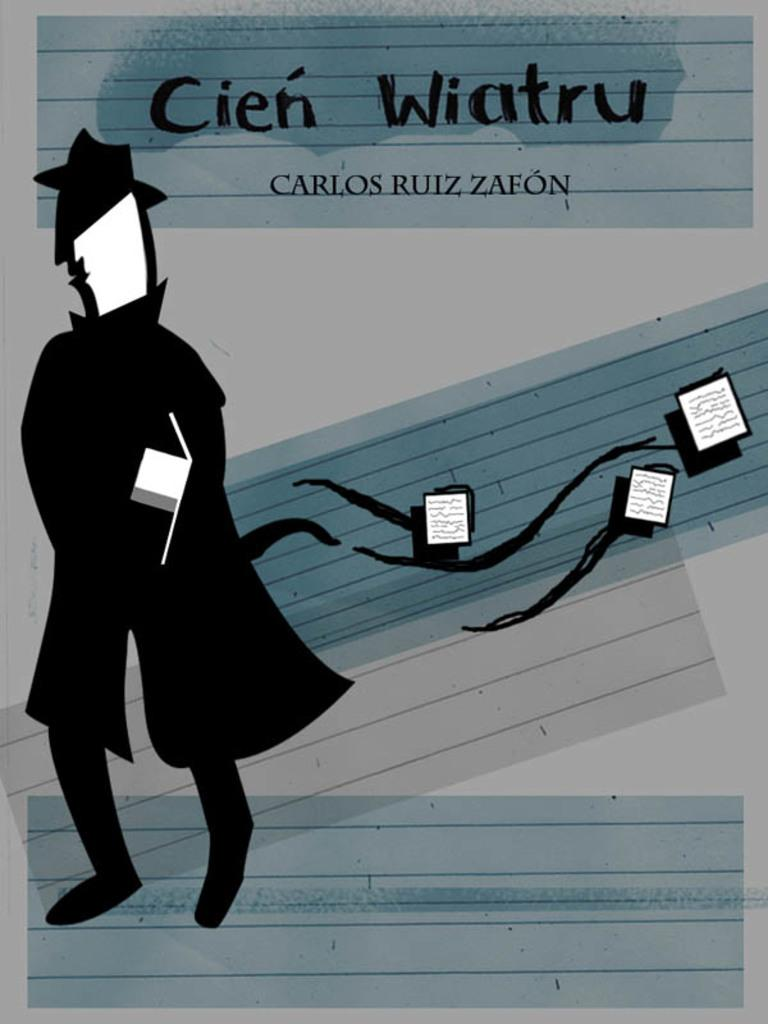What is present in the image that contains both text and a picture? There is a poster in the image that contains text and a picture. Can you describe the content of the poster? The poster contains text and a picture, but the specific content cannot be determined from the provided facts. How many cacti are depicted in the poster? There is no information about cacti in the image or the poster, so it cannot be determined. What invention is being advertised on the poster? There is no information about an invention being advertised on the poster, so it cannot be determined. 